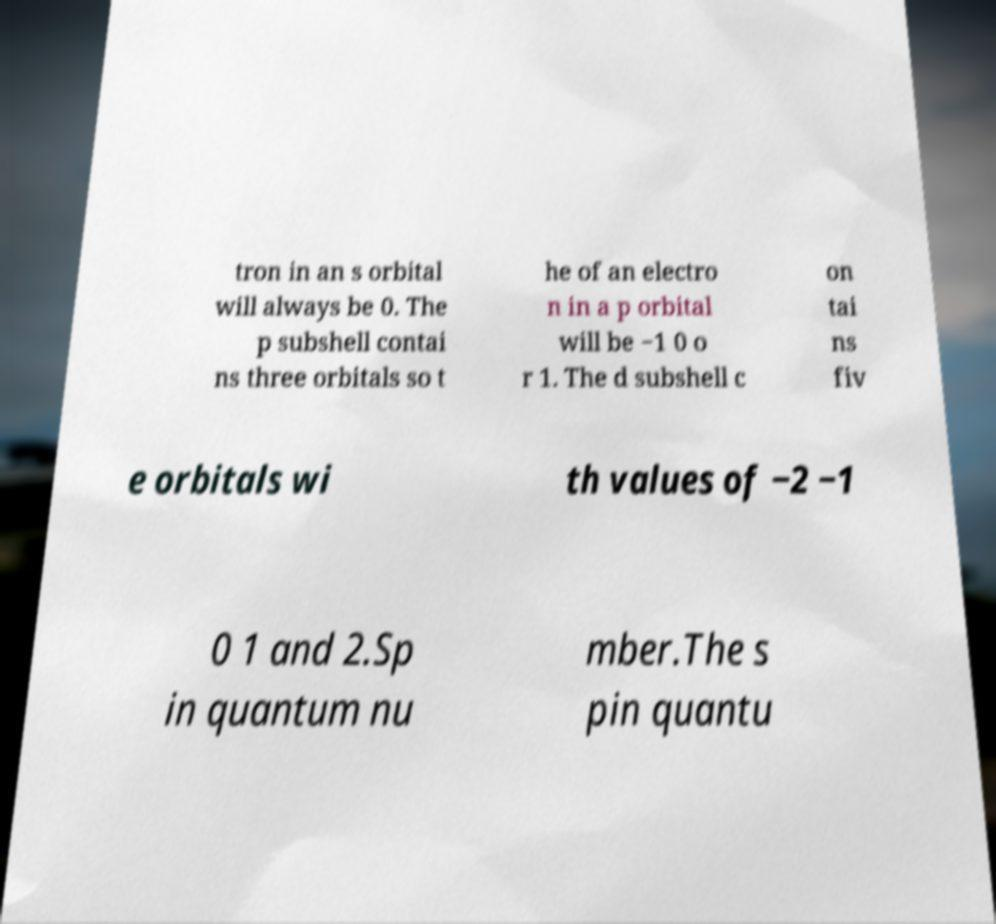Please identify and transcribe the text found in this image. tron in an s orbital will always be 0. The p subshell contai ns three orbitals so t he of an electro n in a p orbital will be −1 0 o r 1. The d subshell c on tai ns fiv e orbitals wi th values of −2 −1 0 1 and 2.Sp in quantum nu mber.The s pin quantu 